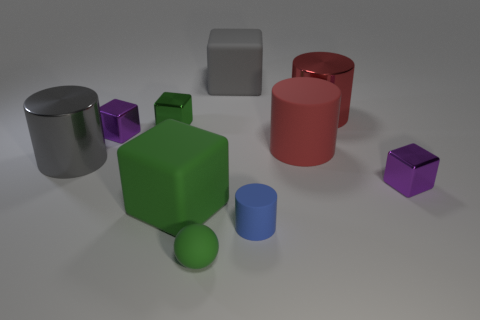What can you infer about the lighting source in this image? The lighting in the image appears to be coming from the top-left, as evidenced by the shadows being cast to the bottom-right of each object. The light source is diffused, resulting in soft shadows with a gentle gradient from light to dark, suggesting an environment with natural or ambient lighting rather than direct spotlighting. 